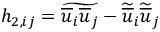Convert formula to latex. <formula><loc_0><loc_0><loc_500><loc_500>h _ { 2 , i j } = \widetilde { \overline { u } _ { i } \overline { u } _ { j } } - \widetilde { \overline { u } } _ { i } \widetilde { \overline { u } } _ { j }</formula> 